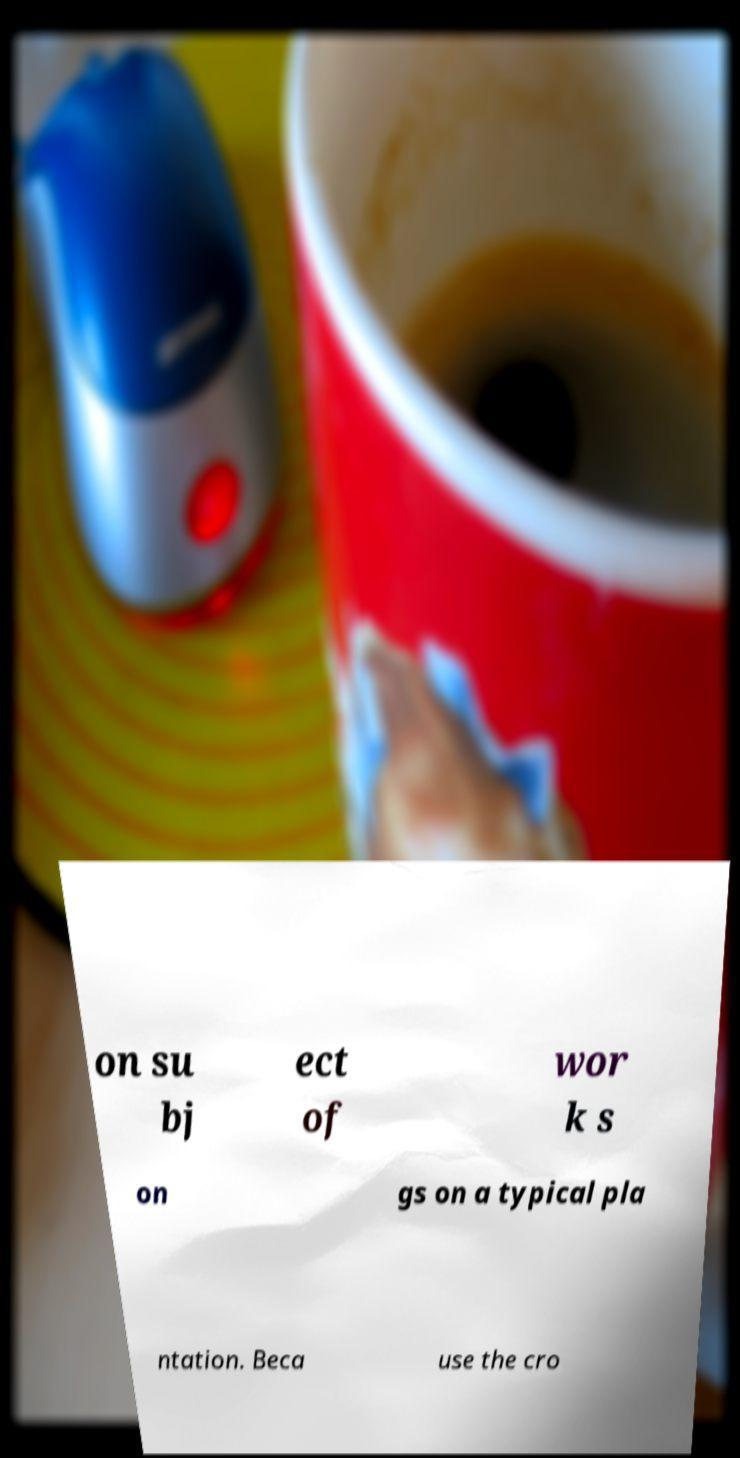Please read and relay the text visible in this image. What does it say? on su bj ect of wor k s on gs on a typical pla ntation. Beca use the cro 